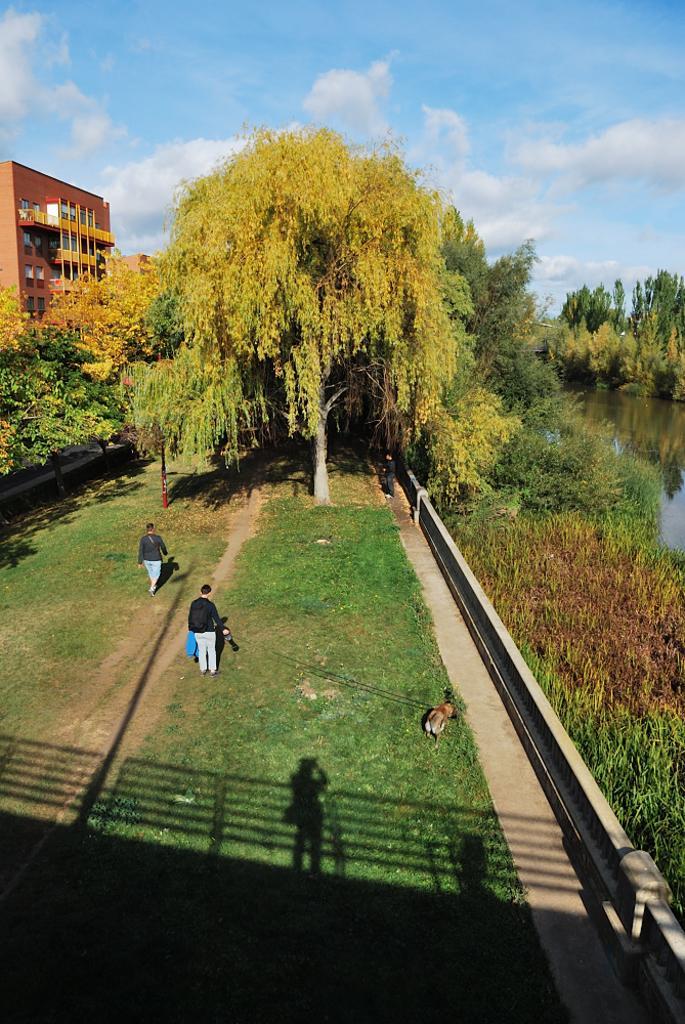Describe this image in one or two sentences. In this picture we can see few people, grass and an animal, in the background we can find few trees, a building and clouds, on the right side of the image we can see water. 